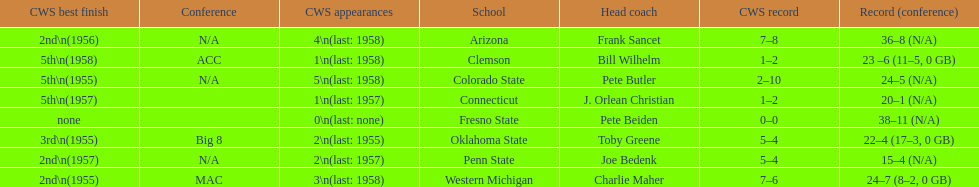Which was the only team with less than 20 wins? Penn State. 